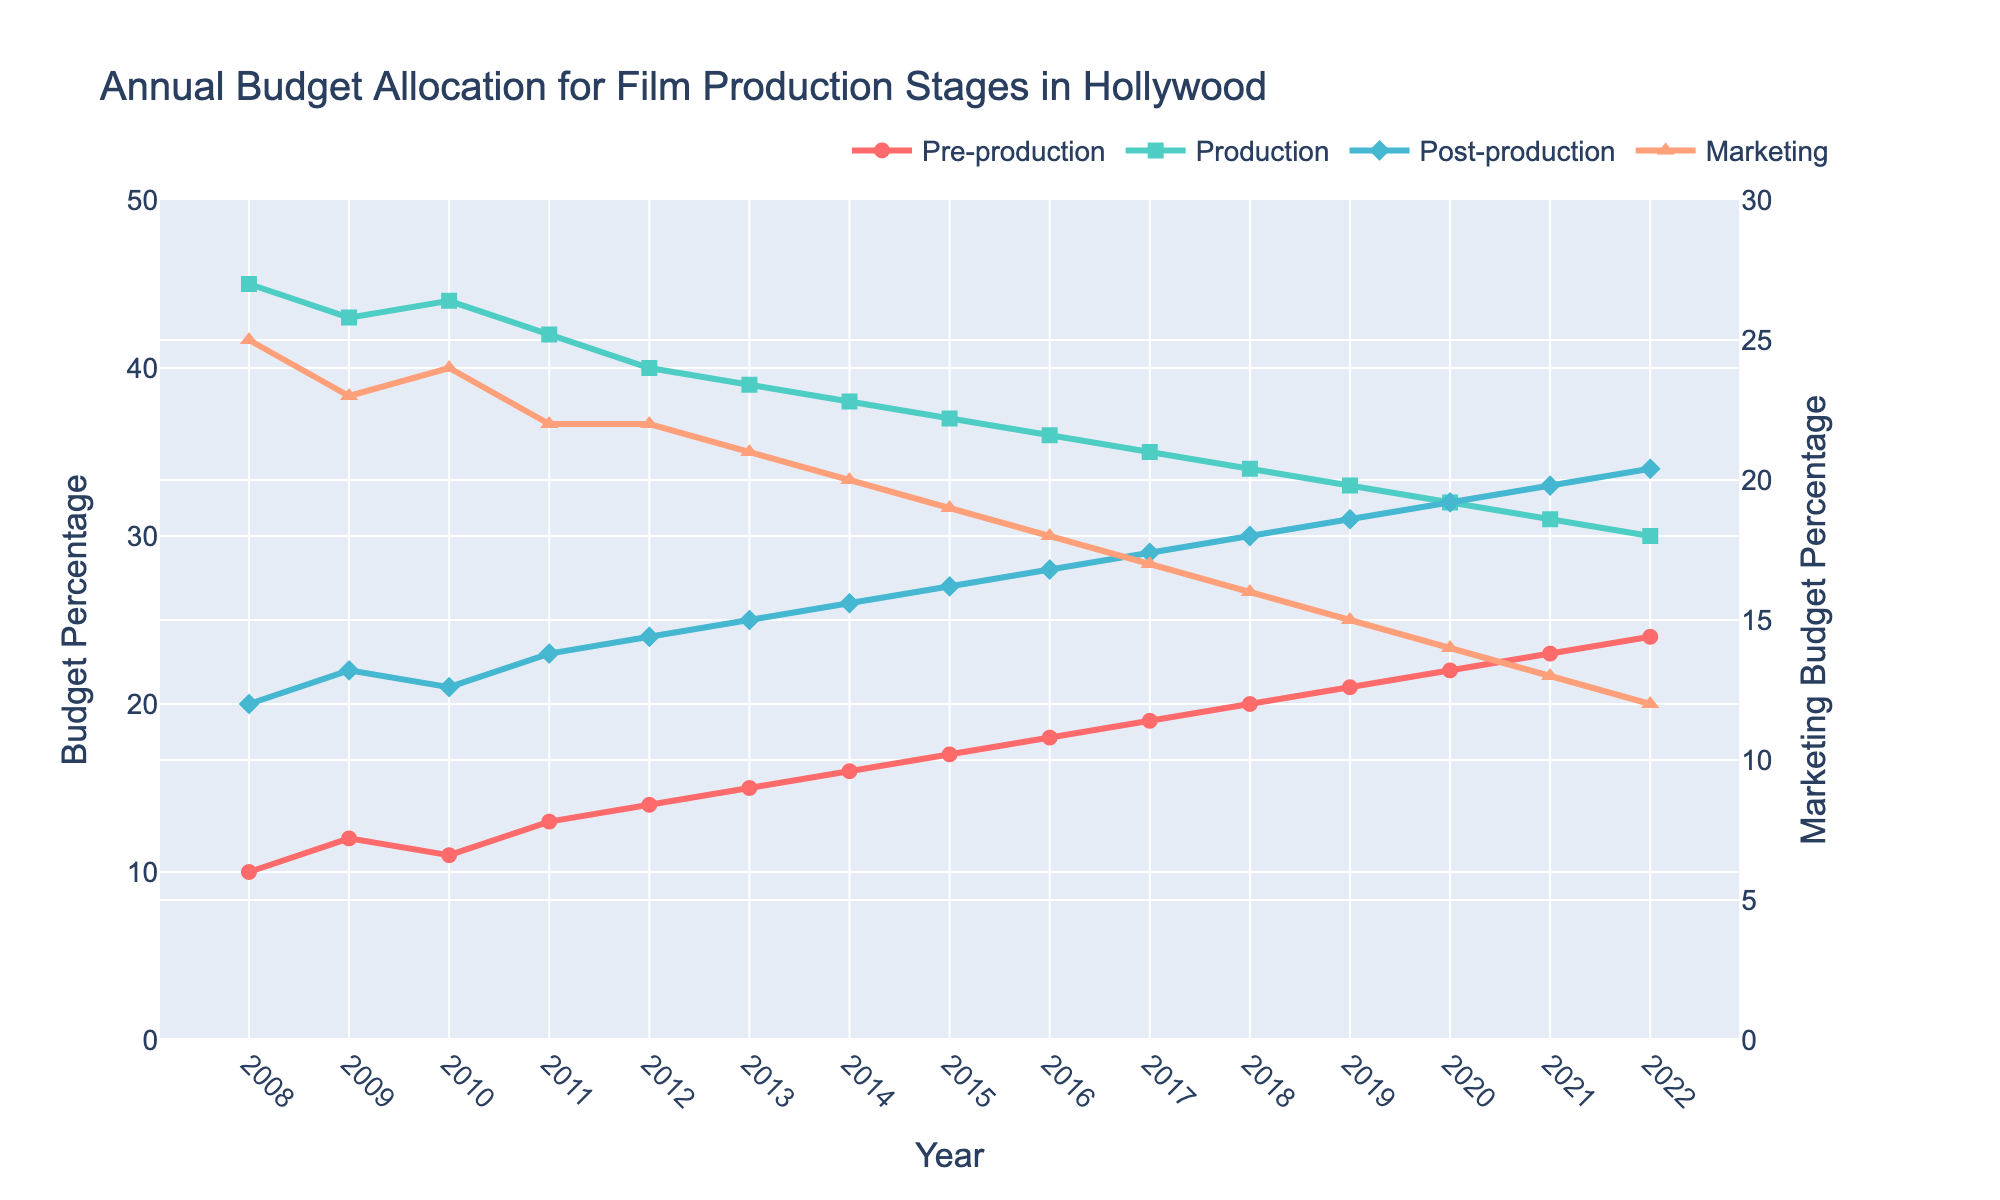What is the overall trend in the marketing budget percentage from 2008 to 2022? Examine the line for the marketing budget. It starts at 25% in 2008 and declines steadily year by year to reach 12% in 2022.
Answer: Decreasing Which year shows the highest budget allocation for pre-production? Look at the line representing the pre-production budget. The highest point occurs in 2022 where it reaches 24%.
Answer: 2022 In which year was the budget allocation for post-production equal to 29%? Follow the line for post-production and find the year corresponding to where the value is 29%, which happens in 2017.
Answer: 2017 By how much did the production budget change from 2008 to 2018? Compare the production budget percentages in 2008 and 2018. In 2008, it was 45%, and in 2018, it was 34%. The change is 45% - 34% = 11%.
Answer: 11% Compare the budget percentages for production and marketing in 2018. Which one was higher and by how much? In 2018, the production budget was 34% and the marketing budget was 16%. The difference is 34% - 16% = 18%. Production was higher by 18%.
Answer: Production, 18% What is the cumulative budget allocation for pre-production and production in 2015? Add the percentages for pre-production and production in 2015. Pre-production is 17% and production is 37%. The sum is 17% + 37% = 54%.
Answer: 54% Which stage saw the most significant increase in budget allocation from 2008 to 2022? Compare changes in budget percentages for all stages from 2008 to 2022. Pre-production increased from 10% to 24%, production decreased from 45% to 30%, post-production increased from 20% to 34%, and marketing decreased from 25% to 12%. Thus, the most significant increase is in pre-production (24% - 10% = 14%).
Answer: Pre-production How did the post-production budget percentage compare to the marketing budget percentage in 2020? Check the values for post-production and marketing in 2020. Post-production is 32% and marketing is 14%. Post-production was higher.
Answer: Post-production was higher What is the average budget percentage for post-production over the 15 years? Sum the percentages for post-production from 2008 to 2022 and divide by the number of years (15). (20+22+21+23+24+25+26+27+28+29+30+31+32+33+34) / 15 = 27%.
Answer: 27% Which year shows an equal budget allocation of 24% for pre-production and 34% for production? Follow the lines for both pre-production and production. They intersect at 24% for pre-production and 34% for production in the year 2022.
Answer: 2022 